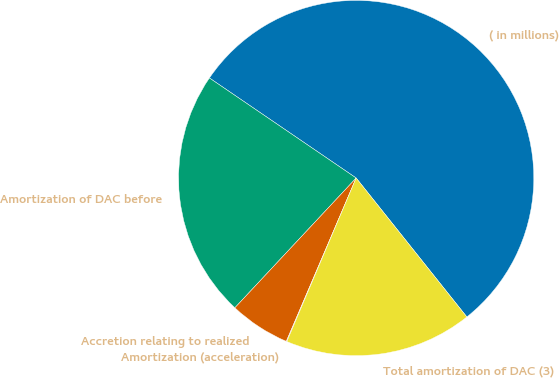Convert chart. <chart><loc_0><loc_0><loc_500><loc_500><pie_chart><fcel>( in millions)<fcel>Amortization of DAC before<fcel>Accretion relating to realized<fcel>Amortization (acceleration)<fcel>Total amortization of DAC (3)<nl><fcel>54.77%<fcel>22.56%<fcel>5.53%<fcel>0.05%<fcel>17.09%<nl></chart> 